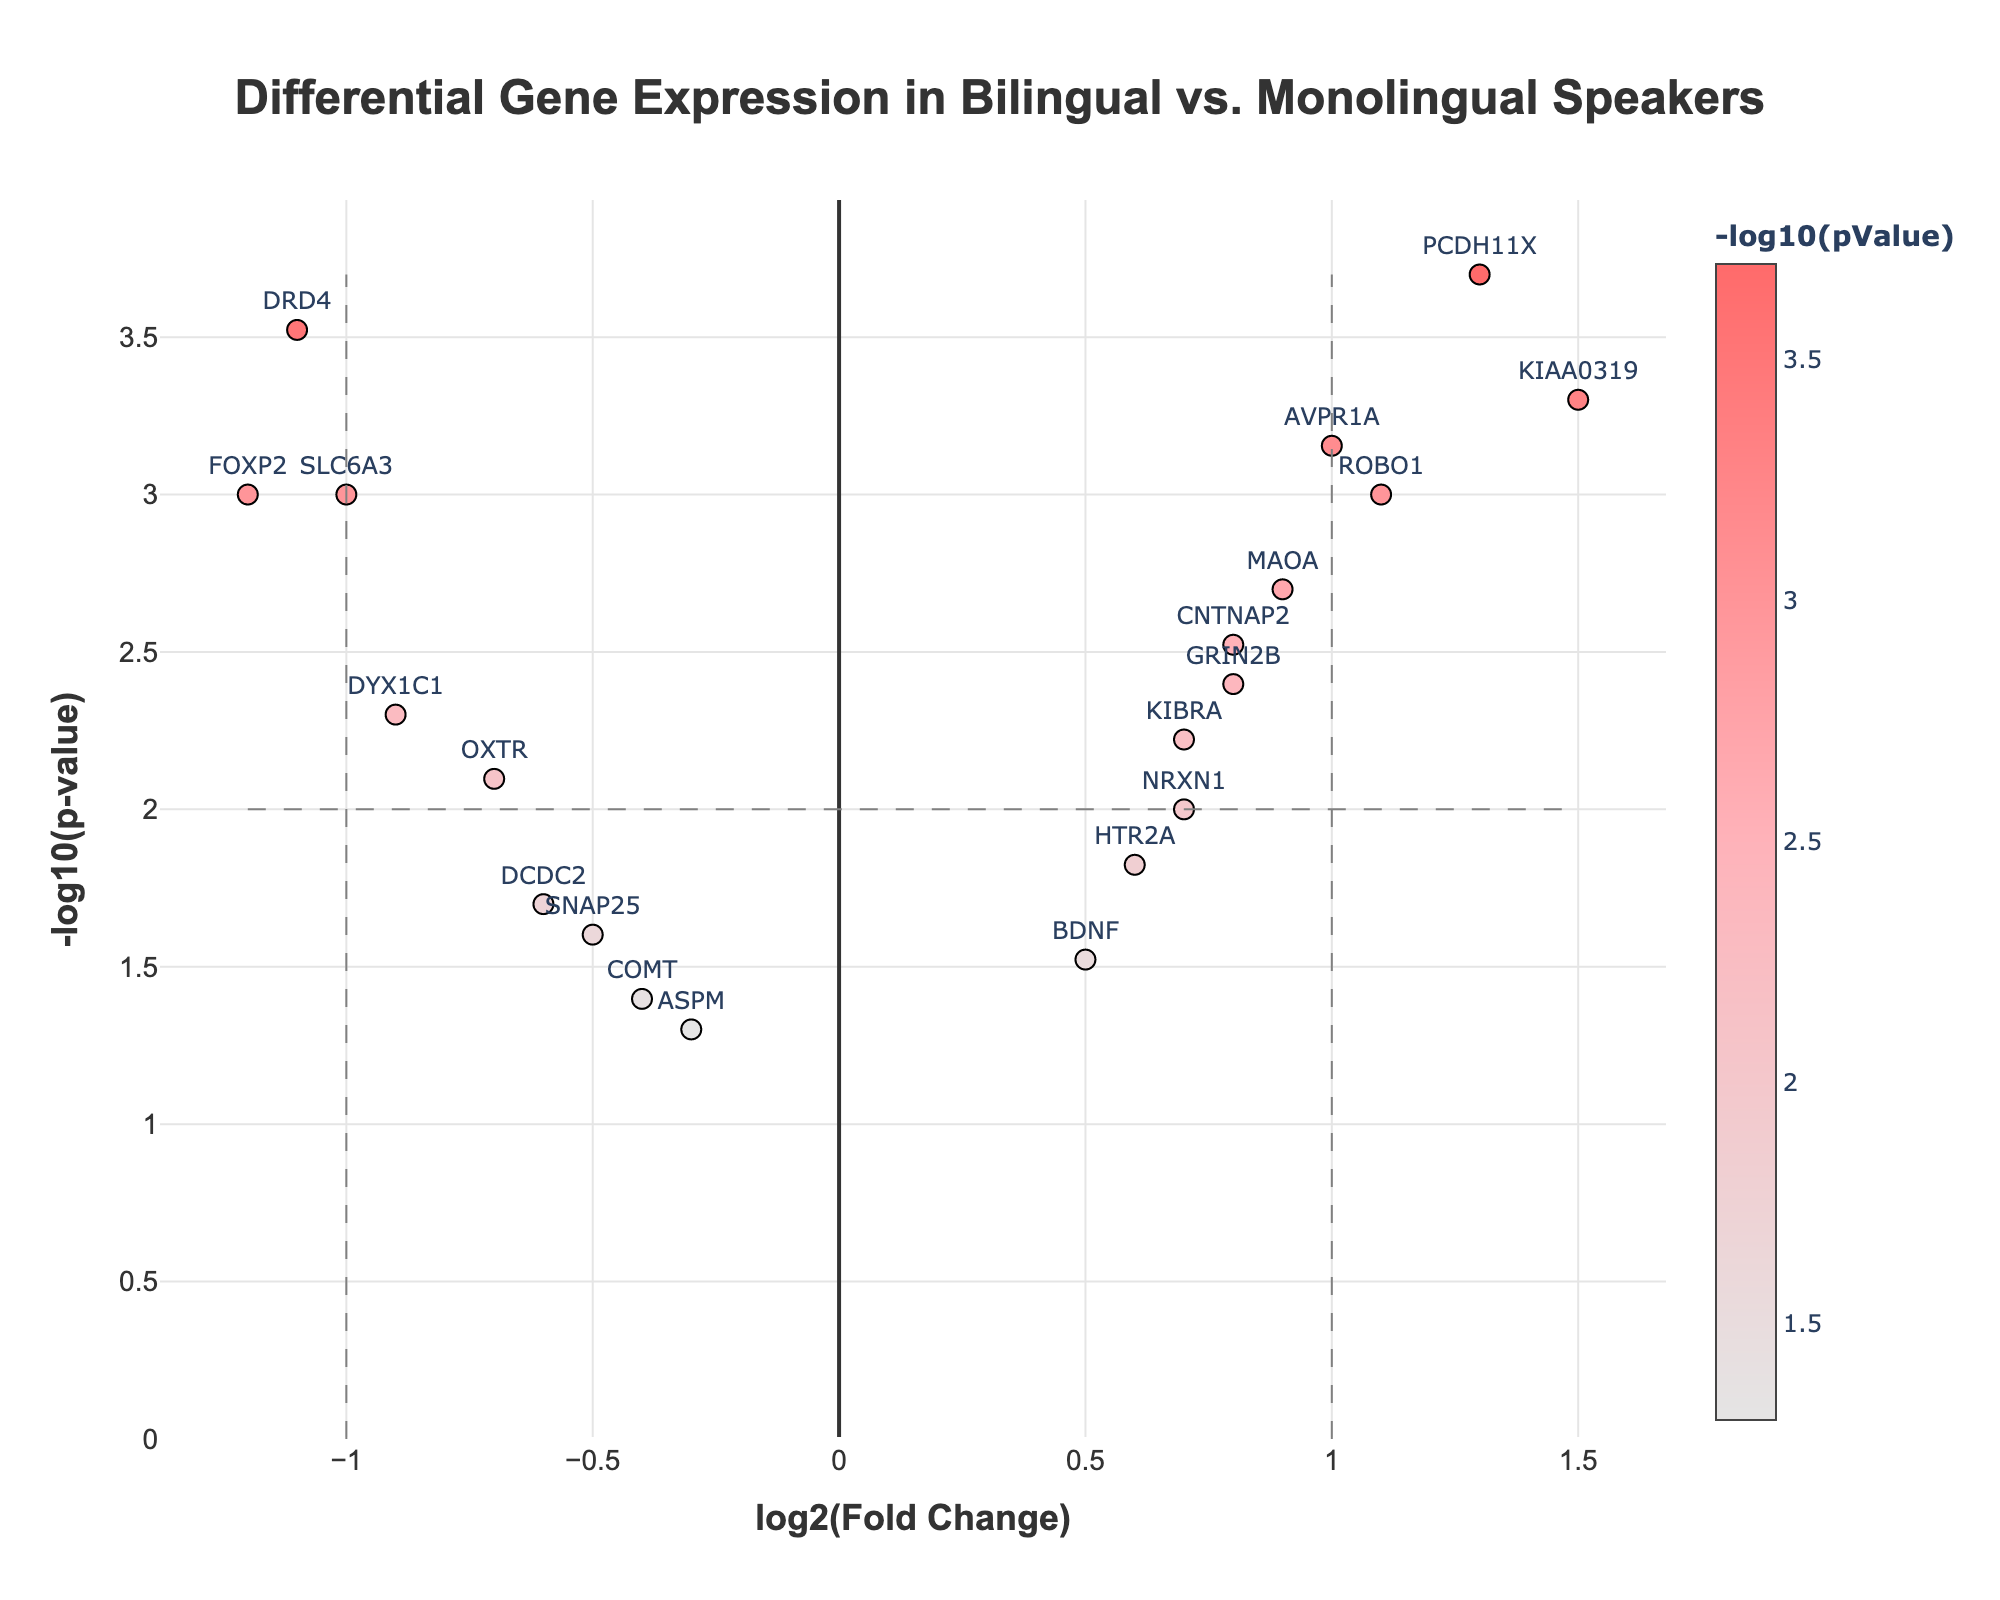How many genes are labeled as "Significant"? Look for the data points categorized as "Significant" which have a distinct visual appearance compared to those labeled as "Not Significant", typically by color. Count these significant points.
Answer: 9 Which gene has the highest log2(Fold Change)? Examine the x-axis for the highest positive value; the corresponding gene label indicates the highest log2(FC).
Answer: KIAA0319 What is the significance threshold for p-value on this plot? Find the horizontal line representing the p-value threshold and refer to the y-axis position. The plot usually includes this threshold as a dotted or dashed line.
Answer: 0.01 What is the -log10(p-value) for FOXP2? Check the y-axis and find the -log10(pValue) for FOXP2, inferred from the data point shown on the plot.
Answer: 3.0 Which gene shows significant downregulation with a p-value less than 0.01? Identify genes below the vertical dashed threshold lines (significant downregulation) with corresponding p-values less than 0.01 along the y-axis.
Answer: DRD4, SLC6A3, FOXP2 Compare the log2(Fold Change) between KIAA0319 and AVPR1A. Which is higher? Locate the position of both genes on the x-axis and compare their log2(FC) values visually.
Answer: KIAA0319 What visual features are used to differentiate between significant and non-significant genes? Observe the distinction in color, outlined markers, or other visual cues used to signify different categories on the plot.
Answer: Color Is the expression of BDNF upregulated or downregulated in bilingual speakers? Check the x-axis position of BDNF; positive values indicate upregulation, negative values indicate downregulation.
Answer: Upregulated List three genes that are upregulated in bilingual speakers with a high degree of significance. Identify genes with positive log2FoldChange and high -log10(p-value) that meet significance criteria.
Answer: KIAA0319, PCDH11X, AVPR1A 